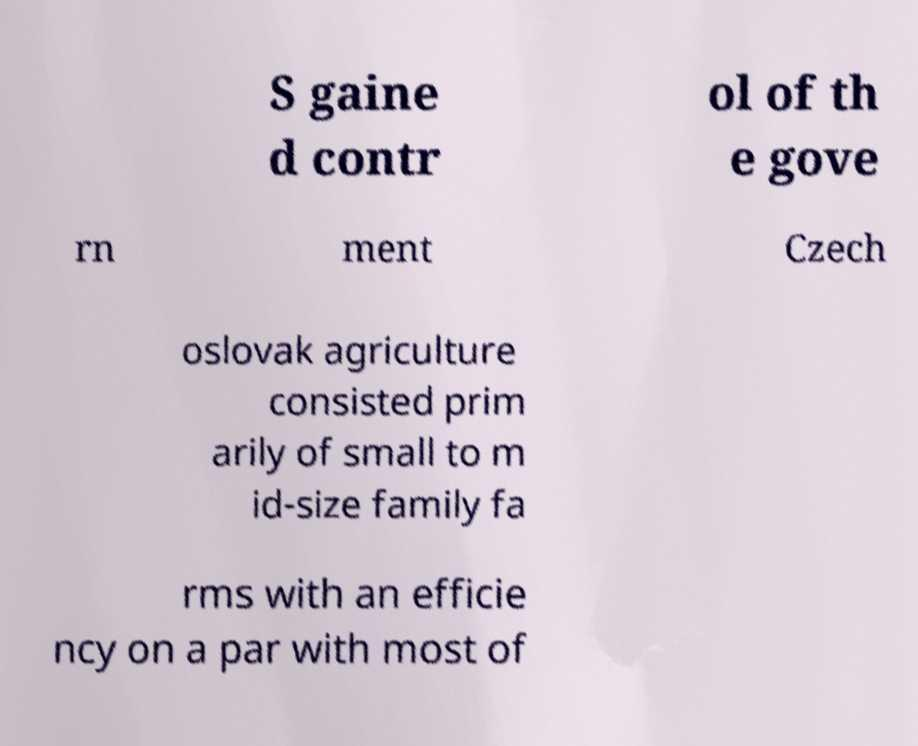There's text embedded in this image that I need extracted. Can you transcribe it verbatim? S gaine d contr ol of th e gove rn ment Czech oslovak agriculture consisted prim arily of small to m id-size family fa rms with an efficie ncy on a par with most of 